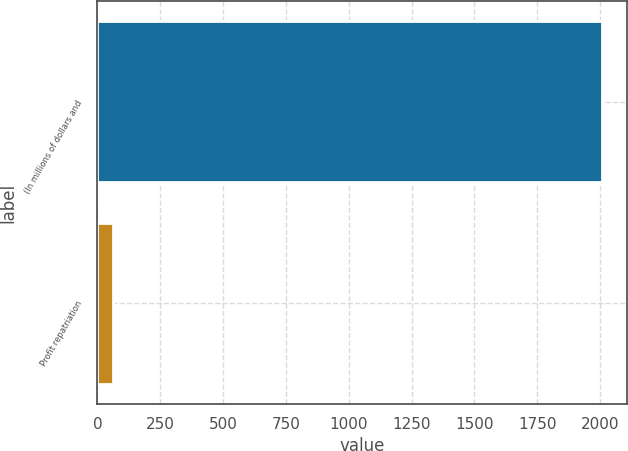Convert chart. <chart><loc_0><loc_0><loc_500><loc_500><bar_chart><fcel>(In millions of dollars and<fcel>Profit repatriation<nl><fcel>2008<fcel>64.1<nl></chart> 